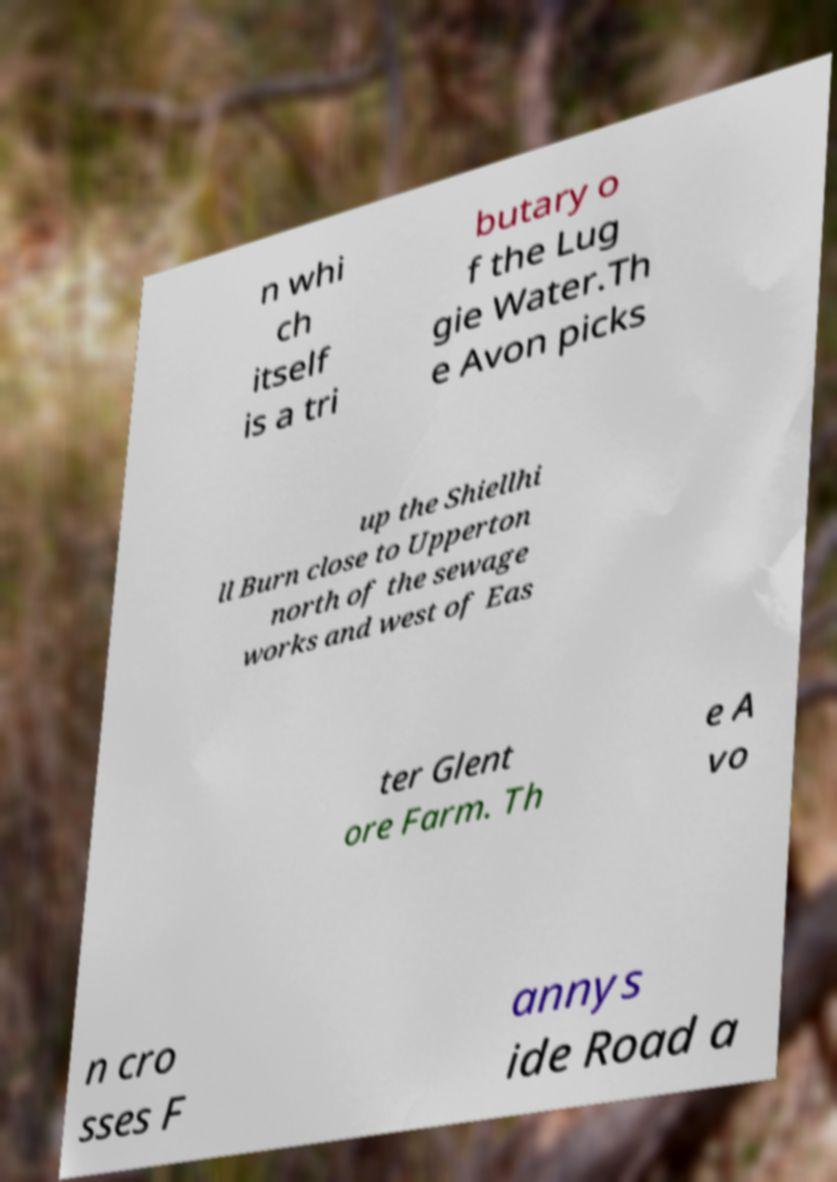For documentation purposes, I need the text within this image transcribed. Could you provide that? n whi ch itself is a tri butary o f the Lug gie Water.Th e Avon picks up the Shiellhi ll Burn close to Upperton north of the sewage works and west of Eas ter Glent ore Farm. Th e A vo n cro sses F annys ide Road a 